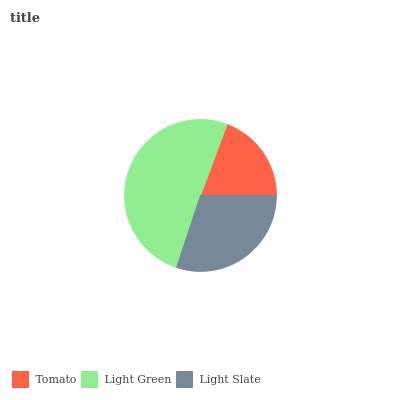Is Tomato the minimum?
Answer yes or no. Yes. Is Light Green the maximum?
Answer yes or no. Yes. Is Light Slate the minimum?
Answer yes or no. No. Is Light Slate the maximum?
Answer yes or no. No. Is Light Green greater than Light Slate?
Answer yes or no. Yes. Is Light Slate less than Light Green?
Answer yes or no. Yes. Is Light Slate greater than Light Green?
Answer yes or no. No. Is Light Green less than Light Slate?
Answer yes or no. No. Is Light Slate the high median?
Answer yes or no. Yes. Is Light Slate the low median?
Answer yes or no. Yes. Is Light Green the high median?
Answer yes or no. No. Is Tomato the low median?
Answer yes or no. No. 